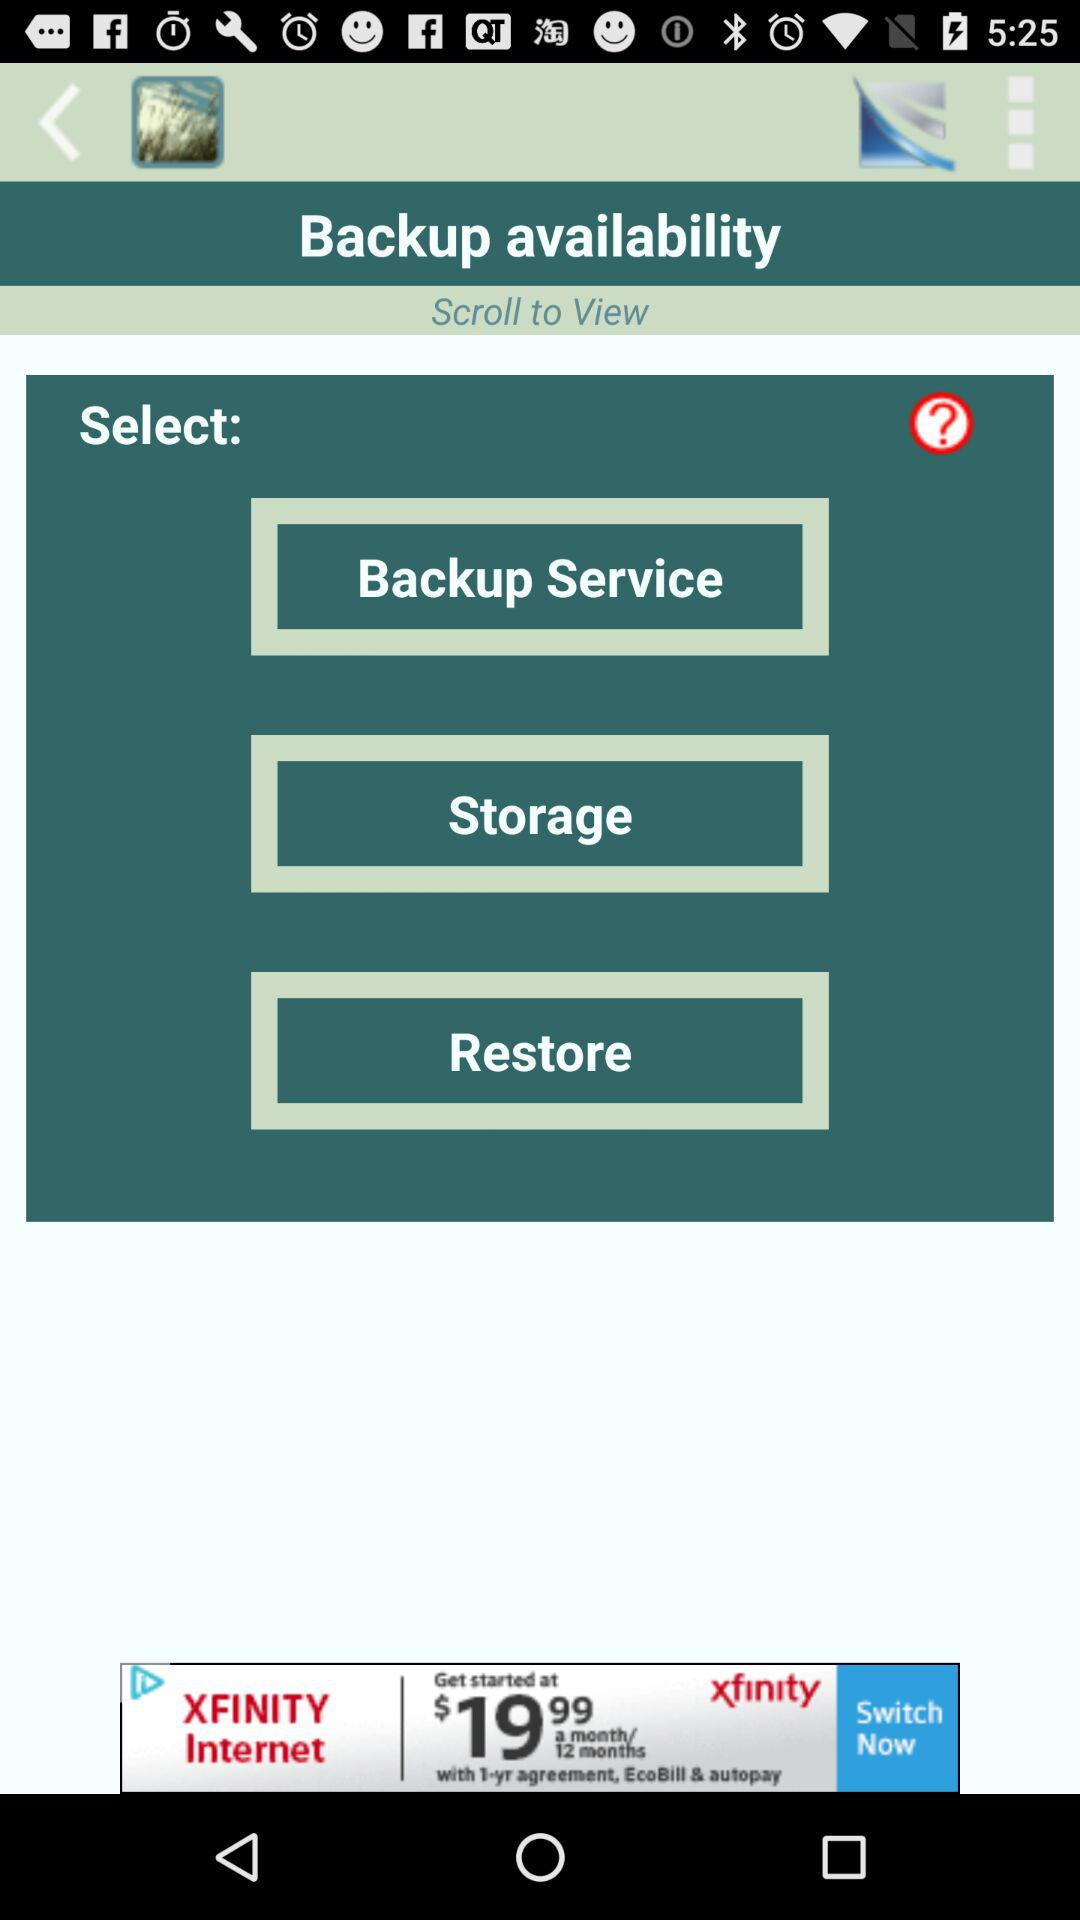Which option is selected?
When the provided information is insufficient, respond with <no answer>. <no answer> 